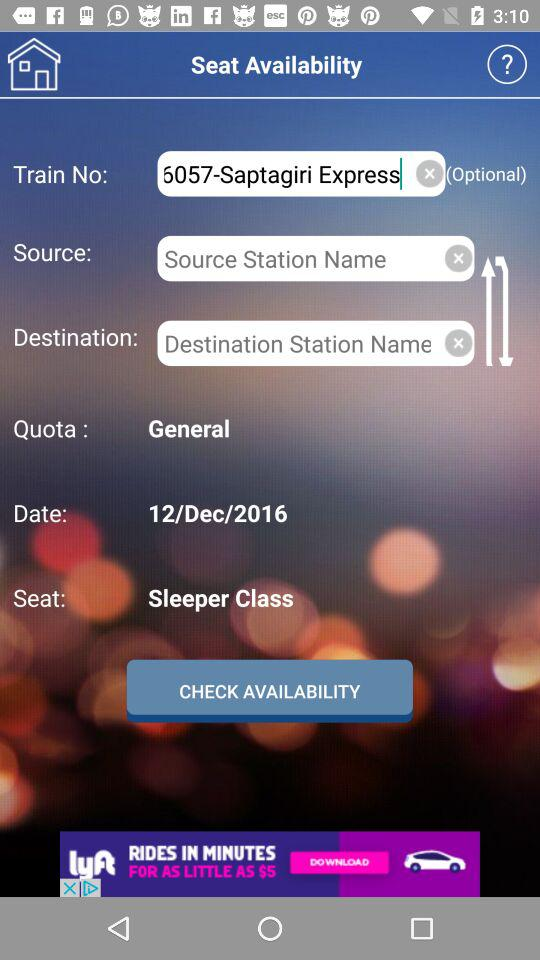How many more text inputs are there for the source and destination fields than for the quota and date fields?
Answer the question using a single word or phrase. 2 